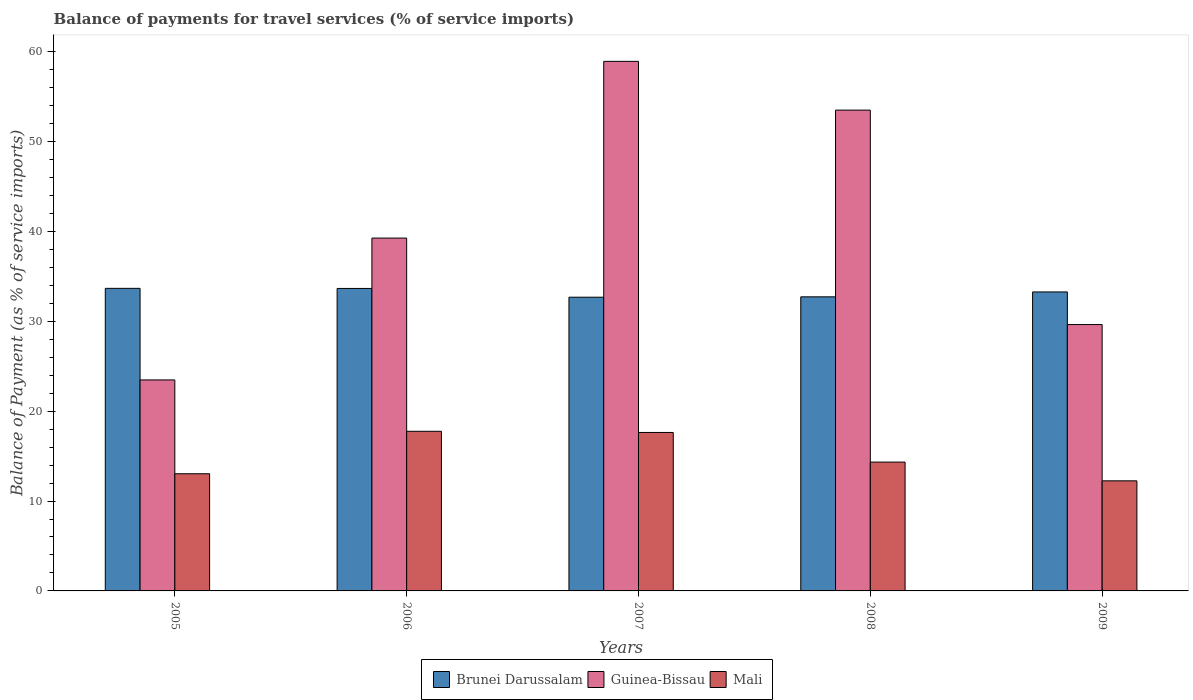How many different coloured bars are there?
Offer a very short reply. 3. How many groups of bars are there?
Your response must be concise. 5. Are the number of bars on each tick of the X-axis equal?
Offer a very short reply. Yes. What is the label of the 1st group of bars from the left?
Keep it short and to the point. 2005. What is the balance of payments for travel services in Mali in 2009?
Keep it short and to the point. 12.25. Across all years, what is the maximum balance of payments for travel services in Mali?
Your answer should be very brief. 17.76. Across all years, what is the minimum balance of payments for travel services in Mali?
Give a very brief answer. 12.25. In which year was the balance of payments for travel services in Mali maximum?
Provide a short and direct response. 2006. What is the total balance of payments for travel services in Brunei Darussalam in the graph?
Make the answer very short. 165.99. What is the difference between the balance of payments for travel services in Guinea-Bissau in 2006 and that in 2009?
Make the answer very short. 9.62. What is the difference between the balance of payments for travel services in Brunei Darussalam in 2005 and the balance of payments for travel services in Mali in 2009?
Provide a short and direct response. 21.42. What is the average balance of payments for travel services in Mali per year?
Your response must be concise. 15. In the year 2005, what is the difference between the balance of payments for travel services in Mali and balance of payments for travel services in Guinea-Bissau?
Offer a terse response. -10.44. In how many years, is the balance of payments for travel services in Mali greater than 38 %?
Ensure brevity in your answer.  0. What is the ratio of the balance of payments for travel services in Guinea-Bissau in 2005 to that in 2006?
Your answer should be very brief. 0.6. Is the difference between the balance of payments for travel services in Mali in 2006 and 2009 greater than the difference between the balance of payments for travel services in Guinea-Bissau in 2006 and 2009?
Make the answer very short. No. What is the difference between the highest and the second highest balance of payments for travel services in Brunei Darussalam?
Ensure brevity in your answer.  0.01. What is the difference between the highest and the lowest balance of payments for travel services in Brunei Darussalam?
Offer a terse response. 0.99. Is the sum of the balance of payments for travel services in Guinea-Bissau in 2006 and 2007 greater than the maximum balance of payments for travel services in Brunei Darussalam across all years?
Provide a succinct answer. Yes. What does the 2nd bar from the left in 2007 represents?
Offer a terse response. Guinea-Bissau. What does the 1st bar from the right in 2008 represents?
Offer a terse response. Mali. Are all the bars in the graph horizontal?
Your answer should be very brief. No. How many years are there in the graph?
Your response must be concise. 5. What is the difference between two consecutive major ticks on the Y-axis?
Your answer should be very brief. 10. Are the values on the major ticks of Y-axis written in scientific E-notation?
Your answer should be compact. No. Does the graph contain any zero values?
Your answer should be very brief. No. Where does the legend appear in the graph?
Make the answer very short. Bottom center. How many legend labels are there?
Provide a short and direct response. 3. What is the title of the graph?
Give a very brief answer. Balance of payments for travel services (% of service imports). Does "Mauritania" appear as one of the legend labels in the graph?
Your response must be concise. No. What is the label or title of the Y-axis?
Give a very brief answer. Balance of Payment (as % of service imports). What is the Balance of Payment (as % of service imports) in Brunei Darussalam in 2005?
Make the answer very short. 33.67. What is the Balance of Payment (as % of service imports) of Guinea-Bissau in 2005?
Your answer should be very brief. 23.48. What is the Balance of Payment (as % of service imports) in Mali in 2005?
Make the answer very short. 13.04. What is the Balance of Payment (as % of service imports) of Brunei Darussalam in 2006?
Keep it short and to the point. 33.66. What is the Balance of Payment (as % of service imports) of Guinea-Bissau in 2006?
Offer a very short reply. 39.26. What is the Balance of Payment (as % of service imports) of Mali in 2006?
Offer a terse response. 17.76. What is the Balance of Payment (as % of service imports) of Brunei Darussalam in 2007?
Keep it short and to the point. 32.68. What is the Balance of Payment (as % of service imports) in Guinea-Bissau in 2007?
Ensure brevity in your answer.  58.92. What is the Balance of Payment (as % of service imports) in Mali in 2007?
Give a very brief answer. 17.63. What is the Balance of Payment (as % of service imports) in Brunei Darussalam in 2008?
Provide a short and direct response. 32.72. What is the Balance of Payment (as % of service imports) in Guinea-Bissau in 2008?
Offer a terse response. 53.5. What is the Balance of Payment (as % of service imports) of Mali in 2008?
Provide a succinct answer. 14.34. What is the Balance of Payment (as % of service imports) of Brunei Darussalam in 2009?
Your answer should be very brief. 33.27. What is the Balance of Payment (as % of service imports) in Guinea-Bissau in 2009?
Provide a succinct answer. 29.64. What is the Balance of Payment (as % of service imports) in Mali in 2009?
Provide a short and direct response. 12.25. Across all years, what is the maximum Balance of Payment (as % of service imports) of Brunei Darussalam?
Ensure brevity in your answer.  33.67. Across all years, what is the maximum Balance of Payment (as % of service imports) of Guinea-Bissau?
Provide a short and direct response. 58.92. Across all years, what is the maximum Balance of Payment (as % of service imports) in Mali?
Your answer should be very brief. 17.76. Across all years, what is the minimum Balance of Payment (as % of service imports) of Brunei Darussalam?
Your response must be concise. 32.68. Across all years, what is the minimum Balance of Payment (as % of service imports) of Guinea-Bissau?
Give a very brief answer. 23.48. Across all years, what is the minimum Balance of Payment (as % of service imports) of Mali?
Your answer should be compact. 12.25. What is the total Balance of Payment (as % of service imports) in Brunei Darussalam in the graph?
Your response must be concise. 165.99. What is the total Balance of Payment (as % of service imports) in Guinea-Bissau in the graph?
Your response must be concise. 204.8. What is the total Balance of Payment (as % of service imports) of Mali in the graph?
Ensure brevity in your answer.  75.01. What is the difference between the Balance of Payment (as % of service imports) in Brunei Darussalam in 2005 and that in 2006?
Provide a succinct answer. 0.01. What is the difference between the Balance of Payment (as % of service imports) in Guinea-Bissau in 2005 and that in 2006?
Offer a terse response. -15.78. What is the difference between the Balance of Payment (as % of service imports) of Mali in 2005 and that in 2006?
Your response must be concise. -4.72. What is the difference between the Balance of Payment (as % of service imports) in Brunei Darussalam in 2005 and that in 2007?
Provide a short and direct response. 0.99. What is the difference between the Balance of Payment (as % of service imports) in Guinea-Bissau in 2005 and that in 2007?
Provide a short and direct response. -35.45. What is the difference between the Balance of Payment (as % of service imports) of Mali in 2005 and that in 2007?
Keep it short and to the point. -4.59. What is the difference between the Balance of Payment (as % of service imports) in Brunei Darussalam in 2005 and that in 2008?
Offer a terse response. 0.94. What is the difference between the Balance of Payment (as % of service imports) of Guinea-Bissau in 2005 and that in 2008?
Your answer should be very brief. -30.02. What is the difference between the Balance of Payment (as % of service imports) in Mali in 2005 and that in 2008?
Provide a succinct answer. -1.3. What is the difference between the Balance of Payment (as % of service imports) of Brunei Darussalam in 2005 and that in 2009?
Provide a succinct answer. 0.4. What is the difference between the Balance of Payment (as % of service imports) in Guinea-Bissau in 2005 and that in 2009?
Provide a succinct answer. -6.16. What is the difference between the Balance of Payment (as % of service imports) of Mali in 2005 and that in 2009?
Your answer should be compact. 0.79. What is the difference between the Balance of Payment (as % of service imports) in Brunei Darussalam in 2006 and that in 2007?
Offer a very short reply. 0.98. What is the difference between the Balance of Payment (as % of service imports) in Guinea-Bissau in 2006 and that in 2007?
Ensure brevity in your answer.  -19.66. What is the difference between the Balance of Payment (as % of service imports) in Mali in 2006 and that in 2007?
Offer a very short reply. 0.13. What is the difference between the Balance of Payment (as % of service imports) in Guinea-Bissau in 2006 and that in 2008?
Offer a very short reply. -14.24. What is the difference between the Balance of Payment (as % of service imports) of Mali in 2006 and that in 2008?
Your response must be concise. 3.43. What is the difference between the Balance of Payment (as % of service imports) in Brunei Darussalam in 2006 and that in 2009?
Provide a succinct answer. 0.39. What is the difference between the Balance of Payment (as % of service imports) of Guinea-Bissau in 2006 and that in 2009?
Provide a succinct answer. 9.62. What is the difference between the Balance of Payment (as % of service imports) of Mali in 2006 and that in 2009?
Give a very brief answer. 5.51. What is the difference between the Balance of Payment (as % of service imports) in Brunei Darussalam in 2007 and that in 2008?
Offer a terse response. -0.04. What is the difference between the Balance of Payment (as % of service imports) of Guinea-Bissau in 2007 and that in 2008?
Your response must be concise. 5.43. What is the difference between the Balance of Payment (as % of service imports) of Mali in 2007 and that in 2008?
Your answer should be very brief. 3.3. What is the difference between the Balance of Payment (as % of service imports) in Brunei Darussalam in 2007 and that in 2009?
Your answer should be very brief. -0.59. What is the difference between the Balance of Payment (as % of service imports) in Guinea-Bissau in 2007 and that in 2009?
Ensure brevity in your answer.  29.29. What is the difference between the Balance of Payment (as % of service imports) in Mali in 2007 and that in 2009?
Make the answer very short. 5.38. What is the difference between the Balance of Payment (as % of service imports) in Brunei Darussalam in 2008 and that in 2009?
Give a very brief answer. -0.54. What is the difference between the Balance of Payment (as % of service imports) of Guinea-Bissau in 2008 and that in 2009?
Your answer should be compact. 23.86. What is the difference between the Balance of Payment (as % of service imports) in Mali in 2008 and that in 2009?
Give a very brief answer. 2.09. What is the difference between the Balance of Payment (as % of service imports) of Brunei Darussalam in 2005 and the Balance of Payment (as % of service imports) of Guinea-Bissau in 2006?
Ensure brevity in your answer.  -5.59. What is the difference between the Balance of Payment (as % of service imports) of Brunei Darussalam in 2005 and the Balance of Payment (as % of service imports) of Mali in 2006?
Make the answer very short. 15.9. What is the difference between the Balance of Payment (as % of service imports) in Guinea-Bissau in 2005 and the Balance of Payment (as % of service imports) in Mali in 2006?
Make the answer very short. 5.71. What is the difference between the Balance of Payment (as % of service imports) of Brunei Darussalam in 2005 and the Balance of Payment (as % of service imports) of Guinea-Bissau in 2007?
Offer a very short reply. -25.26. What is the difference between the Balance of Payment (as % of service imports) of Brunei Darussalam in 2005 and the Balance of Payment (as % of service imports) of Mali in 2007?
Give a very brief answer. 16.04. What is the difference between the Balance of Payment (as % of service imports) of Guinea-Bissau in 2005 and the Balance of Payment (as % of service imports) of Mali in 2007?
Your response must be concise. 5.84. What is the difference between the Balance of Payment (as % of service imports) in Brunei Darussalam in 2005 and the Balance of Payment (as % of service imports) in Guinea-Bissau in 2008?
Your answer should be very brief. -19.83. What is the difference between the Balance of Payment (as % of service imports) of Brunei Darussalam in 2005 and the Balance of Payment (as % of service imports) of Mali in 2008?
Ensure brevity in your answer.  19.33. What is the difference between the Balance of Payment (as % of service imports) of Guinea-Bissau in 2005 and the Balance of Payment (as % of service imports) of Mali in 2008?
Keep it short and to the point. 9.14. What is the difference between the Balance of Payment (as % of service imports) of Brunei Darussalam in 2005 and the Balance of Payment (as % of service imports) of Guinea-Bissau in 2009?
Your answer should be very brief. 4.03. What is the difference between the Balance of Payment (as % of service imports) in Brunei Darussalam in 2005 and the Balance of Payment (as % of service imports) in Mali in 2009?
Offer a very short reply. 21.42. What is the difference between the Balance of Payment (as % of service imports) in Guinea-Bissau in 2005 and the Balance of Payment (as % of service imports) in Mali in 2009?
Keep it short and to the point. 11.23. What is the difference between the Balance of Payment (as % of service imports) of Brunei Darussalam in 2006 and the Balance of Payment (as % of service imports) of Guinea-Bissau in 2007?
Offer a very short reply. -25.27. What is the difference between the Balance of Payment (as % of service imports) in Brunei Darussalam in 2006 and the Balance of Payment (as % of service imports) in Mali in 2007?
Provide a succinct answer. 16.03. What is the difference between the Balance of Payment (as % of service imports) of Guinea-Bissau in 2006 and the Balance of Payment (as % of service imports) of Mali in 2007?
Your answer should be very brief. 21.63. What is the difference between the Balance of Payment (as % of service imports) in Brunei Darussalam in 2006 and the Balance of Payment (as % of service imports) in Guinea-Bissau in 2008?
Your response must be concise. -19.84. What is the difference between the Balance of Payment (as % of service imports) of Brunei Darussalam in 2006 and the Balance of Payment (as % of service imports) of Mali in 2008?
Provide a short and direct response. 19.32. What is the difference between the Balance of Payment (as % of service imports) in Guinea-Bissau in 2006 and the Balance of Payment (as % of service imports) in Mali in 2008?
Give a very brief answer. 24.93. What is the difference between the Balance of Payment (as % of service imports) in Brunei Darussalam in 2006 and the Balance of Payment (as % of service imports) in Guinea-Bissau in 2009?
Keep it short and to the point. 4.02. What is the difference between the Balance of Payment (as % of service imports) of Brunei Darussalam in 2006 and the Balance of Payment (as % of service imports) of Mali in 2009?
Provide a short and direct response. 21.41. What is the difference between the Balance of Payment (as % of service imports) in Guinea-Bissau in 2006 and the Balance of Payment (as % of service imports) in Mali in 2009?
Offer a terse response. 27.01. What is the difference between the Balance of Payment (as % of service imports) in Brunei Darussalam in 2007 and the Balance of Payment (as % of service imports) in Guinea-Bissau in 2008?
Your response must be concise. -20.82. What is the difference between the Balance of Payment (as % of service imports) of Brunei Darussalam in 2007 and the Balance of Payment (as % of service imports) of Mali in 2008?
Your answer should be compact. 18.35. What is the difference between the Balance of Payment (as % of service imports) of Guinea-Bissau in 2007 and the Balance of Payment (as % of service imports) of Mali in 2008?
Give a very brief answer. 44.59. What is the difference between the Balance of Payment (as % of service imports) in Brunei Darussalam in 2007 and the Balance of Payment (as % of service imports) in Guinea-Bissau in 2009?
Your answer should be very brief. 3.04. What is the difference between the Balance of Payment (as % of service imports) in Brunei Darussalam in 2007 and the Balance of Payment (as % of service imports) in Mali in 2009?
Provide a short and direct response. 20.43. What is the difference between the Balance of Payment (as % of service imports) in Guinea-Bissau in 2007 and the Balance of Payment (as % of service imports) in Mali in 2009?
Your answer should be very brief. 46.68. What is the difference between the Balance of Payment (as % of service imports) in Brunei Darussalam in 2008 and the Balance of Payment (as % of service imports) in Guinea-Bissau in 2009?
Provide a succinct answer. 3.08. What is the difference between the Balance of Payment (as % of service imports) of Brunei Darussalam in 2008 and the Balance of Payment (as % of service imports) of Mali in 2009?
Ensure brevity in your answer.  20.47. What is the difference between the Balance of Payment (as % of service imports) of Guinea-Bissau in 2008 and the Balance of Payment (as % of service imports) of Mali in 2009?
Provide a short and direct response. 41.25. What is the average Balance of Payment (as % of service imports) of Brunei Darussalam per year?
Offer a very short reply. 33.2. What is the average Balance of Payment (as % of service imports) in Guinea-Bissau per year?
Keep it short and to the point. 40.96. What is the average Balance of Payment (as % of service imports) in Mali per year?
Provide a succinct answer. 15. In the year 2005, what is the difference between the Balance of Payment (as % of service imports) in Brunei Darussalam and Balance of Payment (as % of service imports) in Guinea-Bissau?
Your answer should be very brief. 10.19. In the year 2005, what is the difference between the Balance of Payment (as % of service imports) of Brunei Darussalam and Balance of Payment (as % of service imports) of Mali?
Give a very brief answer. 20.63. In the year 2005, what is the difference between the Balance of Payment (as % of service imports) of Guinea-Bissau and Balance of Payment (as % of service imports) of Mali?
Your response must be concise. 10.44. In the year 2006, what is the difference between the Balance of Payment (as % of service imports) in Brunei Darussalam and Balance of Payment (as % of service imports) in Guinea-Bissau?
Keep it short and to the point. -5.6. In the year 2006, what is the difference between the Balance of Payment (as % of service imports) in Brunei Darussalam and Balance of Payment (as % of service imports) in Mali?
Your response must be concise. 15.89. In the year 2006, what is the difference between the Balance of Payment (as % of service imports) in Guinea-Bissau and Balance of Payment (as % of service imports) in Mali?
Provide a succinct answer. 21.5. In the year 2007, what is the difference between the Balance of Payment (as % of service imports) of Brunei Darussalam and Balance of Payment (as % of service imports) of Guinea-Bissau?
Ensure brevity in your answer.  -26.24. In the year 2007, what is the difference between the Balance of Payment (as % of service imports) in Brunei Darussalam and Balance of Payment (as % of service imports) in Mali?
Offer a terse response. 15.05. In the year 2007, what is the difference between the Balance of Payment (as % of service imports) in Guinea-Bissau and Balance of Payment (as % of service imports) in Mali?
Provide a succinct answer. 41.29. In the year 2008, what is the difference between the Balance of Payment (as % of service imports) of Brunei Darussalam and Balance of Payment (as % of service imports) of Guinea-Bissau?
Your answer should be compact. -20.78. In the year 2008, what is the difference between the Balance of Payment (as % of service imports) of Brunei Darussalam and Balance of Payment (as % of service imports) of Mali?
Keep it short and to the point. 18.39. In the year 2008, what is the difference between the Balance of Payment (as % of service imports) in Guinea-Bissau and Balance of Payment (as % of service imports) in Mali?
Keep it short and to the point. 39.16. In the year 2009, what is the difference between the Balance of Payment (as % of service imports) of Brunei Darussalam and Balance of Payment (as % of service imports) of Guinea-Bissau?
Provide a succinct answer. 3.63. In the year 2009, what is the difference between the Balance of Payment (as % of service imports) in Brunei Darussalam and Balance of Payment (as % of service imports) in Mali?
Offer a terse response. 21.02. In the year 2009, what is the difference between the Balance of Payment (as % of service imports) in Guinea-Bissau and Balance of Payment (as % of service imports) in Mali?
Offer a very short reply. 17.39. What is the ratio of the Balance of Payment (as % of service imports) in Brunei Darussalam in 2005 to that in 2006?
Ensure brevity in your answer.  1. What is the ratio of the Balance of Payment (as % of service imports) of Guinea-Bissau in 2005 to that in 2006?
Your answer should be compact. 0.6. What is the ratio of the Balance of Payment (as % of service imports) of Mali in 2005 to that in 2006?
Keep it short and to the point. 0.73. What is the ratio of the Balance of Payment (as % of service imports) in Brunei Darussalam in 2005 to that in 2007?
Offer a terse response. 1.03. What is the ratio of the Balance of Payment (as % of service imports) in Guinea-Bissau in 2005 to that in 2007?
Your answer should be very brief. 0.4. What is the ratio of the Balance of Payment (as % of service imports) of Mali in 2005 to that in 2007?
Keep it short and to the point. 0.74. What is the ratio of the Balance of Payment (as % of service imports) in Brunei Darussalam in 2005 to that in 2008?
Offer a very short reply. 1.03. What is the ratio of the Balance of Payment (as % of service imports) in Guinea-Bissau in 2005 to that in 2008?
Make the answer very short. 0.44. What is the ratio of the Balance of Payment (as % of service imports) in Mali in 2005 to that in 2008?
Provide a short and direct response. 0.91. What is the ratio of the Balance of Payment (as % of service imports) in Brunei Darussalam in 2005 to that in 2009?
Provide a succinct answer. 1.01. What is the ratio of the Balance of Payment (as % of service imports) in Guinea-Bissau in 2005 to that in 2009?
Ensure brevity in your answer.  0.79. What is the ratio of the Balance of Payment (as % of service imports) of Mali in 2005 to that in 2009?
Your answer should be compact. 1.06. What is the ratio of the Balance of Payment (as % of service imports) in Brunei Darussalam in 2006 to that in 2007?
Keep it short and to the point. 1.03. What is the ratio of the Balance of Payment (as % of service imports) of Guinea-Bissau in 2006 to that in 2007?
Ensure brevity in your answer.  0.67. What is the ratio of the Balance of Payment (as % of service imports) of Mali in 2006 to that in 2007?
Offer a terse response. 1.01. What is the ratio of the Balance of Payment (as % of service imports) of Brunei Darussalam in 2006 to that in 2008?
Ensure brevity in your answer.  1.03. What is the ratio of the Balance of Payment (as % of service imports) of Guinea-Bissau in 2006 to that in 2008?
Ensure brevity in your answer.  0.73. What is the ratio of the Balance of Payment (as % of service imports) in Mali in 2006 to that in 2008?
Provide a succinct answer. 1.24. What is the ratio of the Balance of Payment (as % of service imports) in Brunei Darussalam in 2006 to that in 2009?
Make the answer very short. 1.01. What is the ratio of the Balance of Payment (as % of service imports) of Guinea-Bissau in 2006 to that in 2009?
Your response must be concise. 1.32. What is the ratio of the Balance of Payment (as % of service imports) in Mali in 2006 to that in 2009?
Provide a succinct answer. 1.45. What is the ratio of the Balance of Payment (as % of service imports) in Brunei Darussalam in 2007 to that in 2008?
Provide a succinct answer. 1. What is the ratio of the Balance of Payment (as % of service imports) of Guinea-Bissau in 2007 to that in 2008?
Give a very brief answer. 1.1. What is the ratio of the Balance of Payment (as % of service imports) of Mali in 2007 to that in 2008?
Give a very brief answer. 1.23. What is the ratio of the Balance of Payment (as % of service imports) in Brunei Darussalam in 2007 to that in 2009?
Your answer should be compact. 0.98. What is the ratio of the Balance of Payment (as % of service imports) of Guinea-Bissau in 2007 to that in 2009?
Your response must be concise. 1.99. What is the ratio of the Balance of Payment (as % of service imports) in Mali in 2007 to that in 2009?
Your response must be concise. 1.44. What is the ratio of the Balance of Payment (as % of service imports) of Brunei Darussalam in 2008 to that in 2009?
Provide a succinct answer. 0.98. What is the ratio of the Balance of Payment (as % of service imports) in Guinea-Bissau in 2008 to that in 2009?
Provide a succinct answer. 1.8. What is the ratio of the Balance of Payment (as % of service imports) of Mali in 2008 to that in 2009?
Offer a terse response. 1.17. What is the difference between the highest and the second highest Balance of Payment (as % of service imports) of Brunei Darussalam?
Your answer should be very brief. 0.01. What is the difference between the highest and the second highest Balance of Payment (as % of service imports) of Guinea-Bissau?
Make the answer very short. 5.43. What is the difference between the highest and the second highest Balance of Payment (as % of service imports) in Mali?
Ensure brevity in your answer.  0.13. What is the difference between the highest and the lowest Balance of Payment (as % of service imports) of Brunei Darussalam?
Your response must be concise. 0.99. What is the difference between the highest and the lowest Balance of Payment (as % of service imports) in Guinea-Bissau?
Your response must be concise. 35.45. What is the difference between the highest and the lowest Balance of Payment (as % of service imports) of Mali?
Keep it short and to the point. 5.51. 